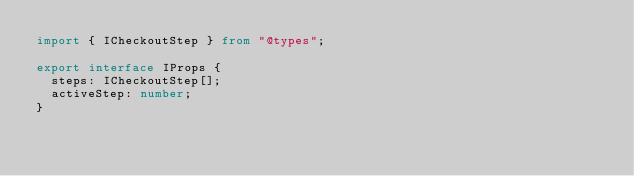<code> <loc_0><loc_0><loc_500><loc_500><_TypeScript_>import { ICheckoutStep } from "@types";

export interface IProps {
  steps: ICheckoutStep[];
  activeStep: number;
}
</code> 